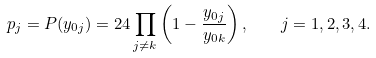<formula> <loc_0><loc_0><loc_500><loc_500>p _ { j } = P ( y _ { 0 j } ) = 2 4 \prod _ { j \neq k } \left ( 1 - \frac { y _ { 0 j } } { y _ { 0 k } } \right ) , \quad j = 1 , 2 , 3 , 4 .</formula> 